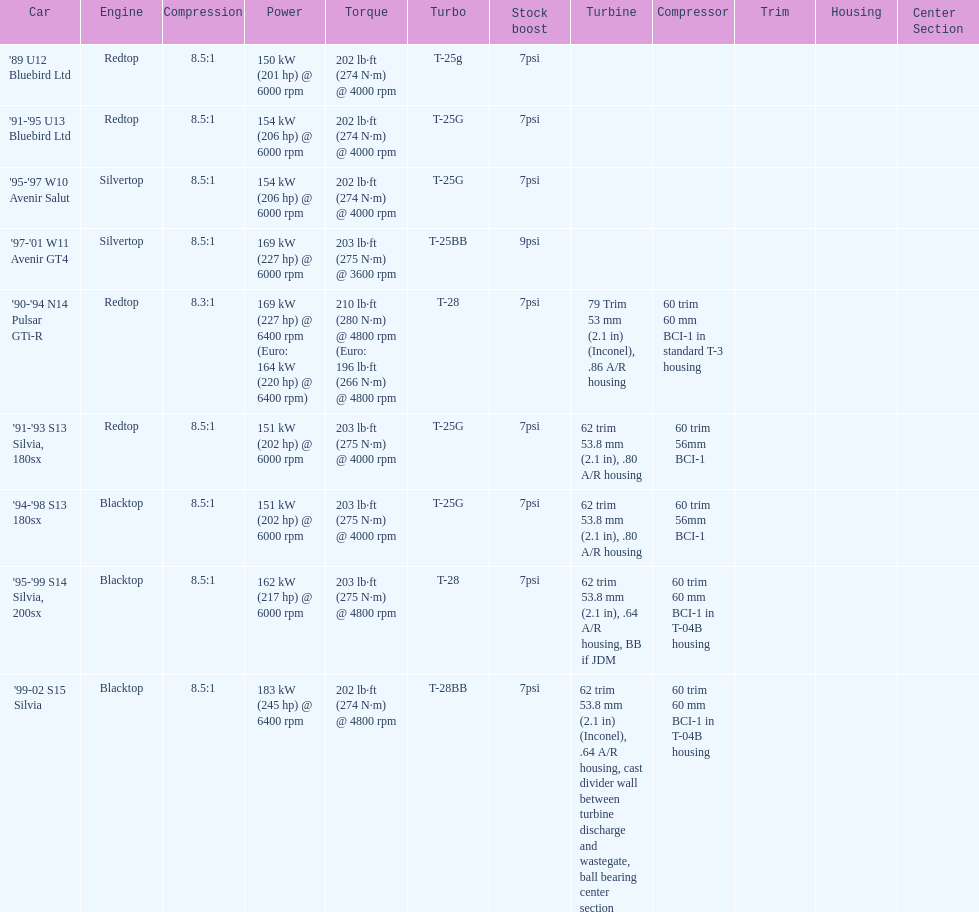Which car is the only one with more than 230 hp? '99-02 S15 Silvia. 